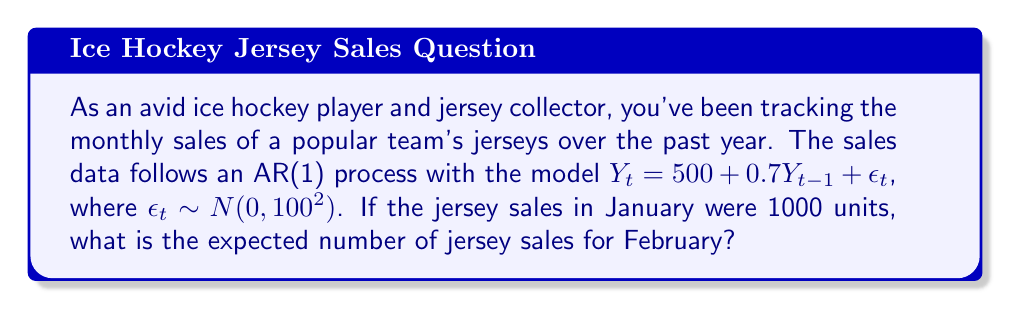What is the answer to this math problem? To solve this problem, we'll use the properties of the AR(1) process and follow these steps:

1) The AR(1) model is given by:
   $Y_t = 500 + 0.7Y_{t-1} + \epsilon_t$

2) We're asked to find the expected value of $Y_t$ given $Y_{t-1} = 1000$. In time series notation, this is written as $E[Y_t | Y_{t-1} = 1000]$.

3) The expected value of $\epsilon_t$ is 0, as it follows a normal distribution with mean 0.

4) Therefore, we can calculate the expected value as follows:

   $E[Y_t | Y_{t-1} = 1000] = E[500 + 0.7Y_{t-1} + \epsilon_t | Y_{t-1} = 1000]$
   
   $= E[500 + 0.7(1000) + \epsilon_t]$
   
   $= 500 + 0.7(1000) + E[\epsilon_t]$
   
   $= 500 + 700 + 0$
   
   $= 1200$

5) Thus, the expected number of jersey sales for February is 1200 units.
Answer: 1200 units 